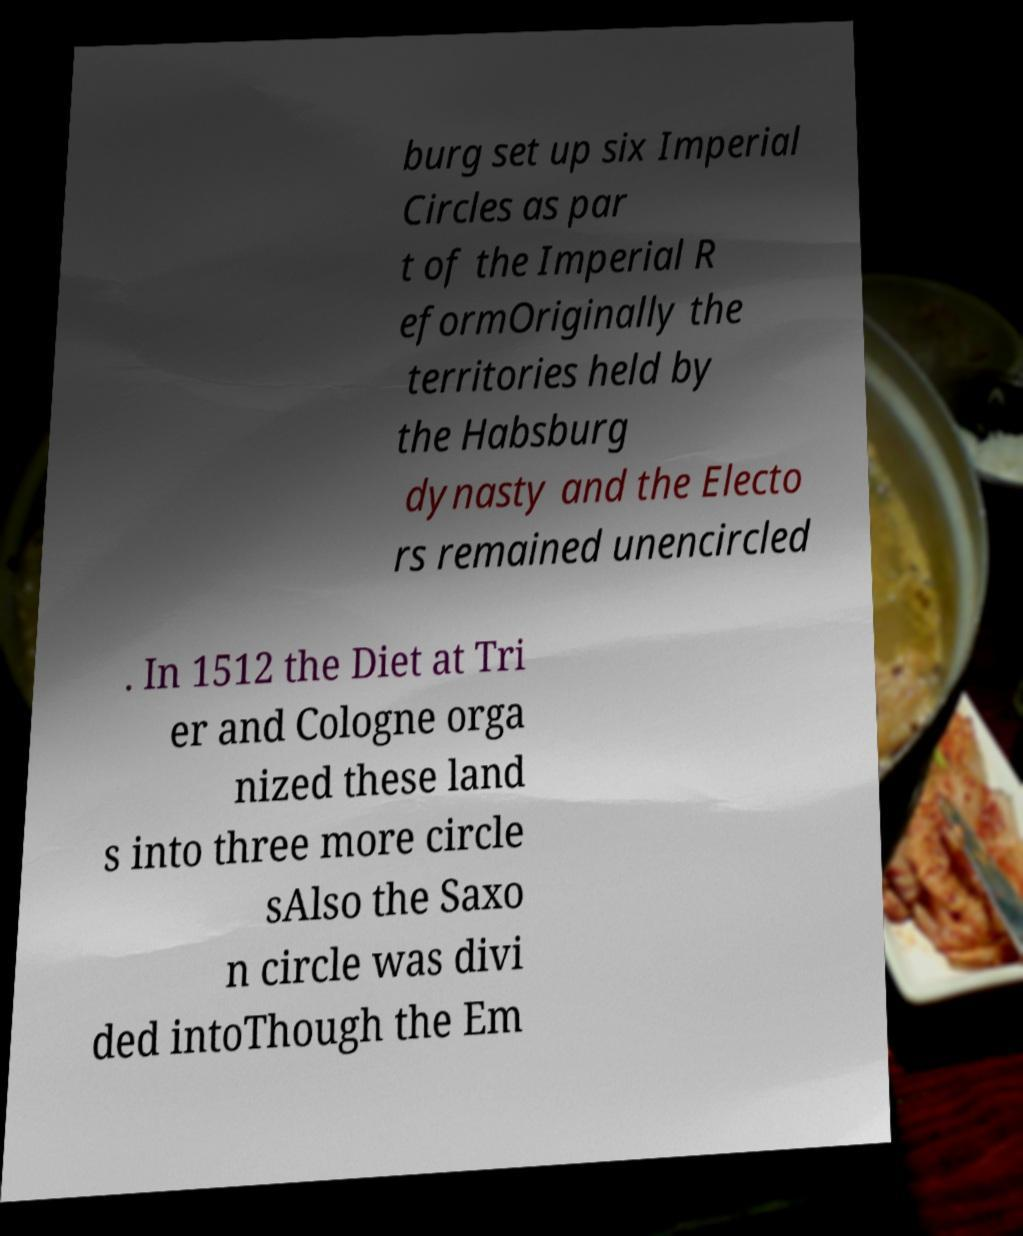There's text embedded in this image that I need extracted. Can you transcribe it verbatim? burg set up six Imperial Circles as par t of the Imperial R eformOriginally the territories held by the Habsburg dynasty and the Electo rs remained unencircled . In 1512 the Diet at Tri er and Cologne orga nized these land s into three more circle sAlso the Saxo n circle was divi ded intoThough the Em 